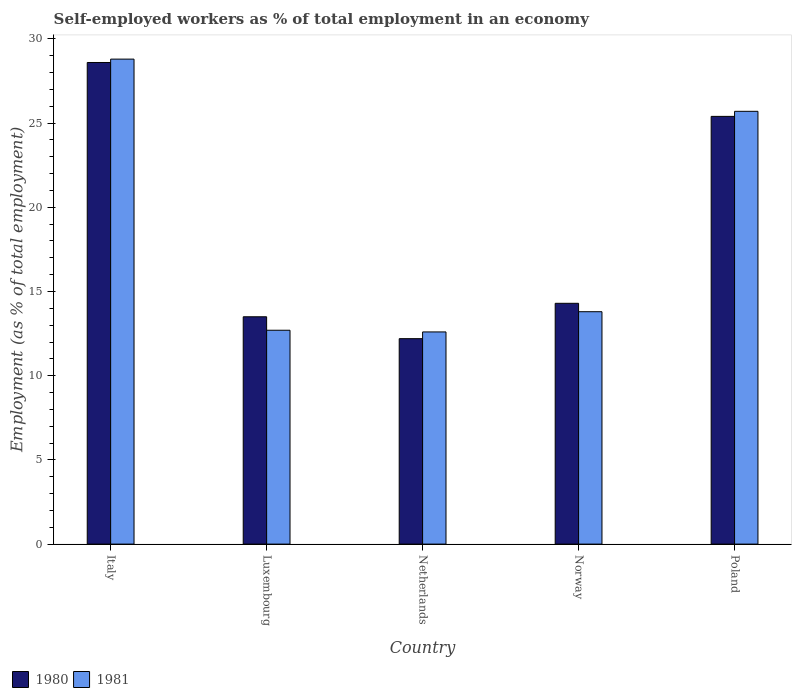Are the number of bars on each tick of the X-axis equal?
Your answer should be very brief. Yes. How many bars are there on the 4th tick from the left?
Give a very brief answer. 2. How many bars are there on the 4th tick from the right?
Give a very brief answer. 2. In how many cases, is the number of bars for a given country not equal to the number of legend labels?
Provide a short and direct response. 0. What is the percentage of self-employed workers in 1980 in Norway?
Your response must be concise. 14.3. Across all countries, what is the maximum percentage of self-employed workers in 1981?
Give a very brief answer. 28.8. Across all countries, what is the minimum percentage of self-employed workers in 1981?
Your response must be concise. 12.6. In which country was the percentage of self-employed workers in 1980 maximum?
Your answer should be very brief. Italy. What is the total percentage of self-employed workers in 1981 in the graph?
Your answer should be compact. 93.6. What is the difference between the percentage of self-employed workers in 1980 in Netherlands and that in Norway?
Offer a very short reply. -2.1. What is the difference between the percentage of self-employed workers in 1980 in Poland and the percentage of self-employed workers in 1981 in Netherlands?
Offer a terse response. 12.8. What is the average percentage of self-employed workers in 1980 per country?
Ensure brevity in your answer.  18.8. What is the difference between the percentage of self-employed workers of/in 1981 and percentage of self-employed workers of/in 1980 in Italy?
Ensure brevity in your answer.  0.2. In how many countries, is the percentage of self-employed workers in 1980 greater than 10 %?
Provide a short and direct response. 5. What is the ratio of the percentage of self-employed workers in 1981 in Luxembourg to that in Netherlands?
Offer a very short reply. 1.01. Is the percentage of self-employed workers in 1980 in Netherlands less than that in Poland?
Provide a short and direct response. Yes. What is the difference between the highest and the second highest percentage of self-employed workers in 1980?
Provide a succinct answer. -3.2. What is the difference between the highest and the lowest percentage of self-employed workers in 1980?
Offer a terse response. 16.4. Is the sum of the percentage of self-employed workers in 1980 in Italy and Poland greater than the maximum percentage of self-employed workers in 1981 across all countries?
Give a very brief answer. Yes. How many bars are there?
Your answer should be compact. 10. Are all the bars in the graph horizontal?
Provide a short and direct response. No. How many countries are there in the graph?
Your response must be concise. 5. Are the values on the major ticks of Y-axis written in scientific E-notation?
Give a very brief answer. No. Does the graph contain grids?
Offer a very short reply. No. How are the legend labels stacked?
Make the answer very short. Horizontal. What is the title of the graph?
Your response must be concise. Self-employed workers as % of total employment in an economy. What is the label or title of the X-axis?
Provide a short and direct response. Country. What is the label or title of the Y-axis?
Give a very brief answer. Employment (as % of total employment). What is the Employment (as % of total employment) of 1980 in Italy?
Keep it short and to the point. 28.6. What is the Employment (as % of total employment) of 1981 in Italy?
Provide a short and direct response. 28.8. What is the Employment (as % of total employment) in 1981 in Luxembourg?
Give a very brief answer. 12.7. What is the Employment (as % of total employment) in 1980 in Netherlands?
Ensure brevity in your answer.  12.2. What is the Employment (as % of total employment) of 1981 in Netherlands?
Provide a succinct answer. 12.6. What is the Employment (as % of total employment) in 1980 in Norway?
Give a very brief answer. 14.3. What is the Employment (as % of total employment) in 1981 in Norway?
Give a very brief answer. 13.8. What is the Employment (as % of total employment) of 1980 in Poland?
Make the answer very short. 25.4. What is the Employment (as % of total employment) in 1981 in Poland?
Your answer should be very brief. 25.7. Across all countries, what is the maximum Employment (as % of total employment) in 1980?
Your answer should be very brief. 28.6. Across all countries, what is the maximum Employment (as % of total employment) in 1981?
Your response must be concise. 28.8. Across all countries, what is the minimum Employment (as % of total employment) of 1980?
Give a very brief answer. 12.2. Across all countries, what is the minimum Employment (as % of total employment) of 1981?
Offer a very short reply. 12.6. What is the total Employment (as % of total employment) of 1980 in the graph?
Ensure brevity in your answer.  94. What is the total Employment (as % of total employment) of 1981 in the graph?
Give a very brief answer. 93.6. What is the difference between the Employment (as % of total employment) in 1980 in Italy and that in Luxembourg?
Give a very brief answer. 15.1. What is the difference between the Employment (as % of total employment) in 1981 in Italy and that in Luxembourg?
Offer a very short reply. 16.1. What is the difference between the Employment (as % of total employment) of 1981 in Italy and that in Poland?
Your response must be concise. 3.1. What is the difference between the Employment (as % of total employment) of 1981 in Luxembourg and that in Netherlands?
Provide a short and direct response. 0.1. What is the difference between the Employment (as % of total employment) in 1981 in Luxembourg and that in Norway?
Provide a succinct answer. -1.1. What is the difference between the Employment (as % of total employment) in 1981 in Luxembourg and that in Poland?
Ensure brevity in your answer.  -13. What is the difference between the Employment (as % of total employment) of 1980 in Netherlands and that in Norway?
Your response must be concise. -2.1. What is the difference between the Employment (as % of total employment) in 1980 in Italy and the Employment (as % of total employment) in 1981 in Luxembourg?
Provide a succinct answer. 15.9. What is the difference between the Employment (as % of total employment) of 1980 in Italy and the Employment (as % of total employment) of 1981 in Norway?
Ensure brevity in your answer.  14.8. What is the difference between the Employment (as % of total employment) in 1980 in Luxembourg and the Employment (as % of total employment) in 1981 in Netherlands?
Provide a succinct answer. 0.9. What is the difference between the Employment (as % of total employment) in 1980 in Luxembourg and the Employment (as % of total employment) in 1981 in Poland?
Give a very brief answer. -12.2. What is the difference between the Employment (as % of total employment) of 1980 in Netherlands and the Employment (as % of total employment) of 1981 in Norway?
Your response must be concise. -1.6. What is the difference between the Employment (as % of total employment) in 1980 in Netherlands and the Employment (as % of total employment) in 1981 in Poland?
Give a very brief answer. -13.5. What is the average Employment (as % of total employment) in 1981 per country?
Ensure brevity in your answer.  18.72. What is the difference between the Employment (as % of total employment) in 1980 and Employment (as % of total employment) in 1981 in Luxembourg?
Your answer should be compact. 0.8. What is the difference between the Employment (as % of total employment) of 1980 and Employment (as % of total employment) of 1981 in Norway?
Provide a short and direct response. 0.5. What is the ratio of the Employment (as % of total employment) in 1980 in Italy to that in Luxembourg?
Your answer should be very brief. 2.12. What is the ratio of the Employment (as % of total employment) in 1981 in Italy to that in Luxembourg?
Your answer should be compact. 2.27. What is the ratio of the Employment (as % of total employment) in 1980 in Italy to that in Netherlands?
Make the answer very short. 2.34. What is the ratio of the Employment (as % of total employment) of 1981 in Italy to that in Netherlands?
Keep it short and to the point. 2.29. What is the ratio of the Employment (as % of total employment) of 1980 in Italy to that in Norway?
Your response must be concise. 2. What is the ratio of the Employment (as % of total employment) in 1981 in Italy to that in Norway?
Offer a terse response. 2.09. What is the ratio of the Employment (as % of total employment) in 1980 in Italy to that in Poland?
Offer a very short reply. 1.13. What is the ratio of the Employment (as % of total employment) of 1981 in Italy to that in Poland?
Offer a terse response. 1.12. What is the ratio of the Employment (as % of total employment) of 1980 in Luxembourg to that in Netherlands?
Provide a succinct answer. 1.11. What is the ratio of the Employment (as % of total employment) of 1981 in Luxembourg to that in Netherlands?
Your answer should be compact. 1.01. What is the ratio of the Employment (as % of total employment) in 1980 in Luxembourg to that in Norway?
Give a very brief answer. 0.94. What is the ratio of the Employment (as % of total employment) of 1981 in Luxembourg to that in Norway?
Provide a succinct answer. 0.92. What is the ratio of the Employment (as % of total employment) in 1980 in Luxembourg to that in Poland?
Give a very brief answer. 0.53. What is the ratio of the Employment (as % of total employment) in 1981 in Luxembourg to that in Poland?
Ensure brevity in your answer.  0.49. What is the ratio of the Employment (as % of total employment) of 1980 in Netherlands to that in Norway?
Offer a very short reply. 0.85. What is the ratio of the Employment (as % of total employment) in 1980 in Netherlands to that in Poland?
Give a very brief answer. 0.48. What is the ratio of the Employment (as % of total employment) of 1981 in Netherlands to that in Poland?
Ensure brevity in your answer.  0.49. What is the ratio of the Employment (as % of total employment) in 1980 in Norway to that in Poland?
Your response must be concise. 0.56. What is the ratio of the Employment (as % of total employment) of 1981 in Norway to that in Poland?
Make the answer very short. 0.54. What is the difference between the highest and the second highest Employment (as % of total employment) of 1980?
Provide a succinct answer. 3.2. What is the difference between the highest and the second highest Employment (as % of total employment) of 1981?
Your answer should be very brief. 3.1. What is the difference between the highest and the lowest Employment (as % of total employment) of 1980?
Keep it short and to the point. 16.4. 